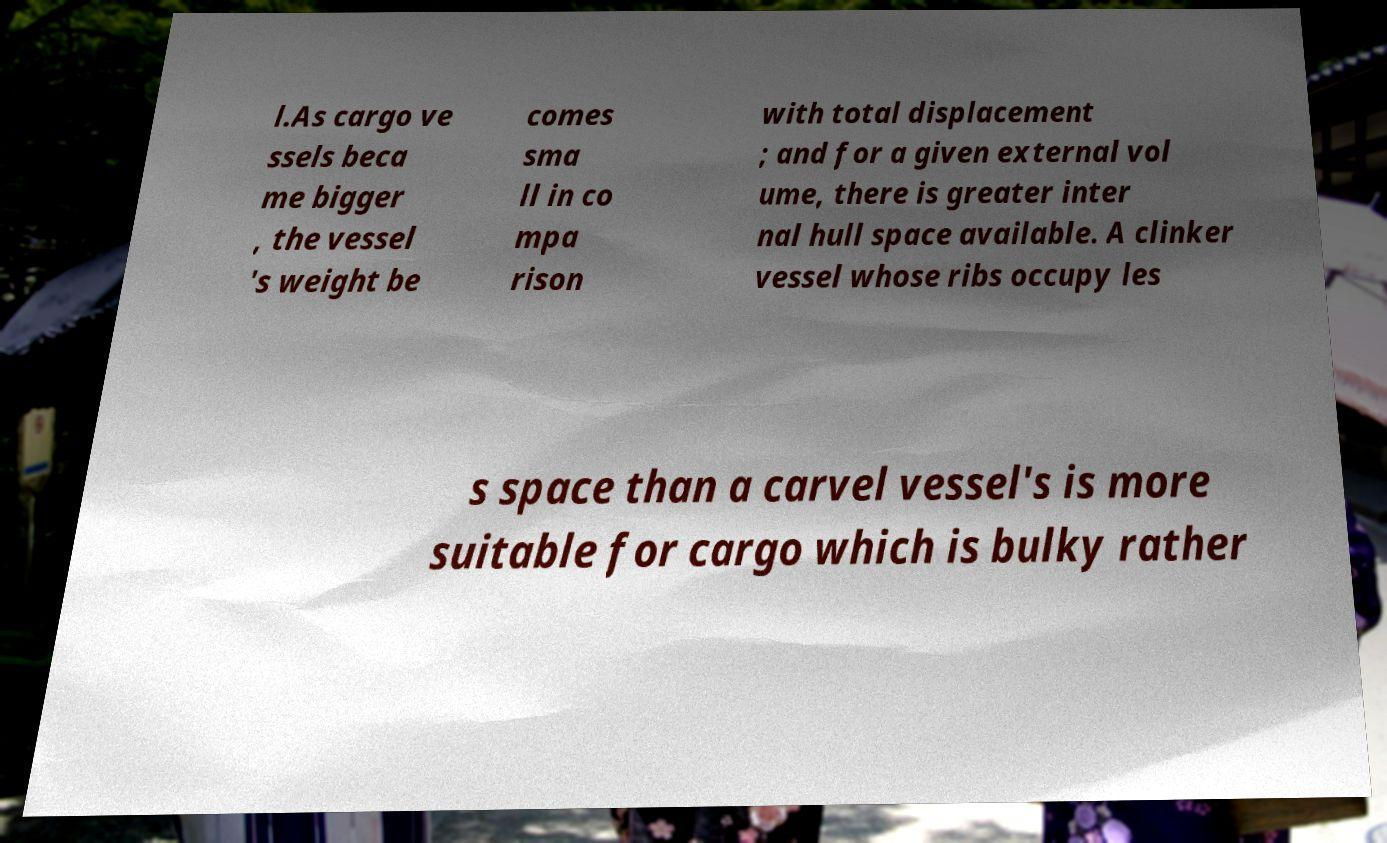Please read and relay the text visible in this image. What does it say? l.As cargo ve ssels beca me bigger , the vessel 's weight be comes sma ll in co mpa rison with total displacement ; and for a given external vol ume, there is greater inter nal hull space available. A clinker vessel whose ribs occupy les s space than a carvel vessel's is more suitable for cargo which is bulky rather 